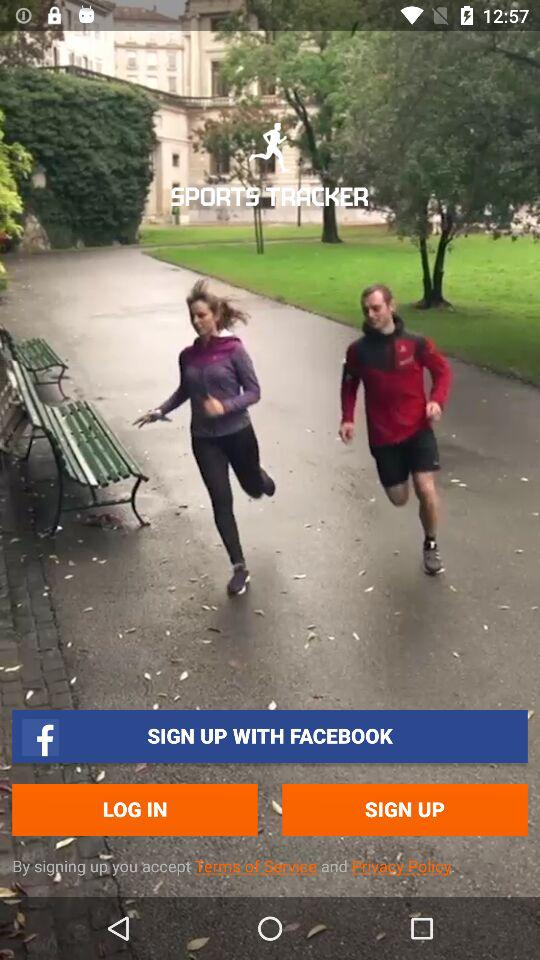How can we sign up? You can sign up with "FACEBOOK". 